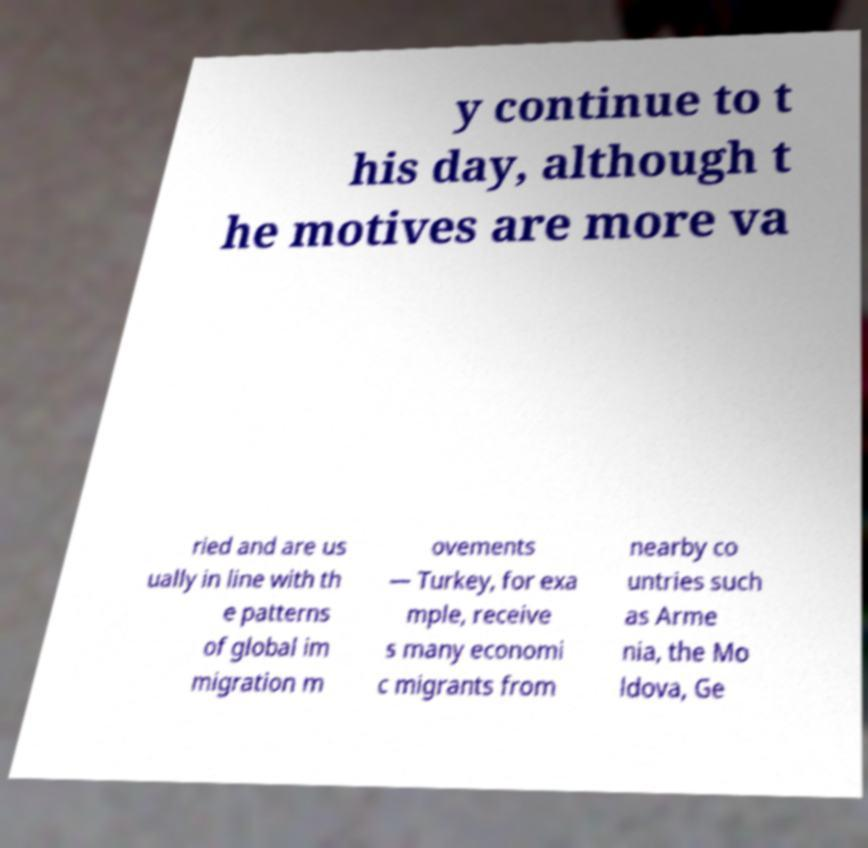What messages or text are displayed in this image? I need them in a readable, typed format. y continue to t his day, although t he motives are more va ried and are us ually in line with th e patterns of global im migration m ovements — Turkey, for exa mple, receive s many economi c migrants from nearby co untries such as Arme nia, the Mo ldova, Ge 